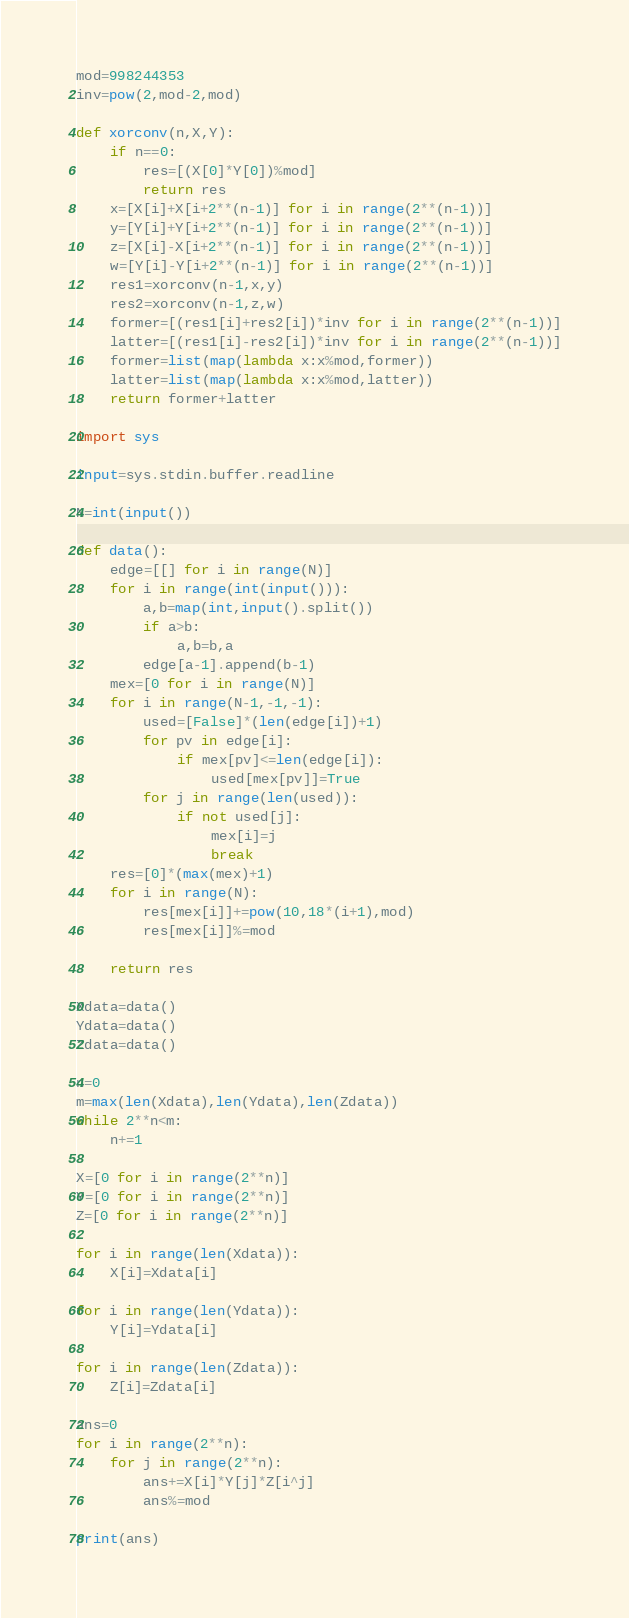Convert code to text. <code><loc_0><loc_0><loc_500><loc_500><_Python_>mod=998244353
inv=pow(2,mod-2,mod)

def xorconv(n,X,Y):
    if n==0:
        res=[(X[0]*Y[0])%mod]
        return res
    x=[X[i]+X[i+2**(n-1)] for i in range(2**(n-1))]
    y=[Y[i]+Y[i+2**(n-1)] for i in range(2**(n-1))]
    z=[X[i]-X[i+2**(n-1)] for i in range(2**(n-1))]
    w=[Y[i]-Y[i+2**(n-1)] for i in range(2**(n-1))]
    res1=xorconv(n-1,x,y)
    res2=xorconv(n-1,z,w)
    former=[(res1[i]+res2[i])*inv for i in range(2**(n-1))]
    latter=[(res1[i]-res2[i])*inv for i in range(2**(n-1))]
    former=list(map(lambda x:x%mod,former))
    latter=list(map(lambda x:x%mod,latter))
    return former+latter

import sys

input=sys.stdin.buffer.readline

N=int(input())

def data():
    edge=[[] for i in range(N)]
    for i in range(int(input())):
        a,b=map(int,input().split())
        if a>b:
            a,b=b,a
        edge[a-1].append(b-1)
    mex=[0 for i in range(N)]
    for i in range(N-1,-1,-1):
        used=[False]*(len(edge[i])+1)
        for pv in edge[i]:
            if mex[pv]<=len(edge[i]):
                used[mex[pv]]=True
        for j in range(len(used)):
            if not used[j]:
                mex[i]=j
                break
    res=[0]*(max(mex)+1)
    for i in range(N):
        res[mex[i]]+=pow(10,18*(i+1),mod)
        res[mex[i]]%=mod

    return res

Xdata=data()
Ydata=data()
Zdata=data()

n=0
m=max(len(Xdata),len(Ydata),len(Zdata))
while 2**n<m:
    n+=1

X=[0 for i in range(2**n)]
Y=[0 for i in range(2**n)]
Z=[0 for i in range(2**n)]

for i in range(len(Xdata)):
    X[i]=Xdata[i]

for i in range(len(Ydata)):
    Y[i]=Ydata[i]

for i in range(len(Zdata)):
    Z[i]=Zdata[i]

ans=0
for i in range(2**n):
    for j in range(2**n):
        ans+=X[i]*Y[j]*Z[i^j]
        ans%=mod

print(ans)
</code> 